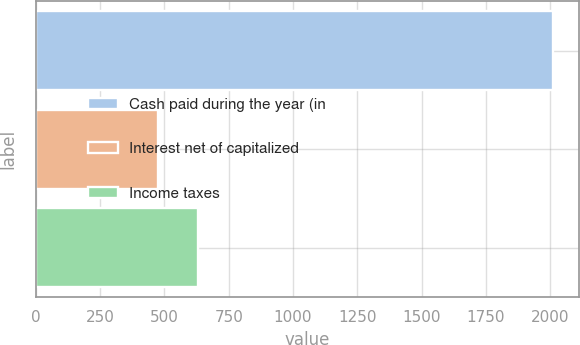<chart> <loc_0><loc_0><loc_500><loc_500><bar_chart><fcel>Cash paid during the year (in<fcel>Interest net of capitalized<fcel>Income taxes<nl><fcel>2010<fcel>477<fcel>630.3<nl></chart> 